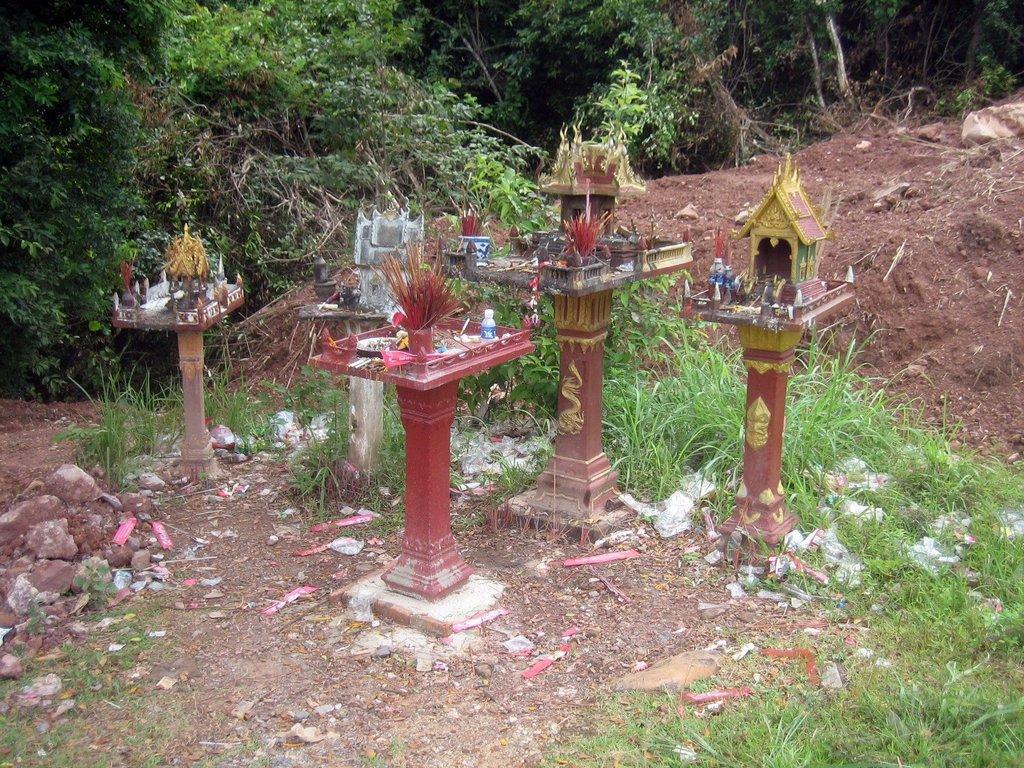In one or two sentences, can you explain what this image depicts? In this image in the center there are some pillars and some baskets, at the bottom there is grass and sand. In the background there are some trees and sand. 